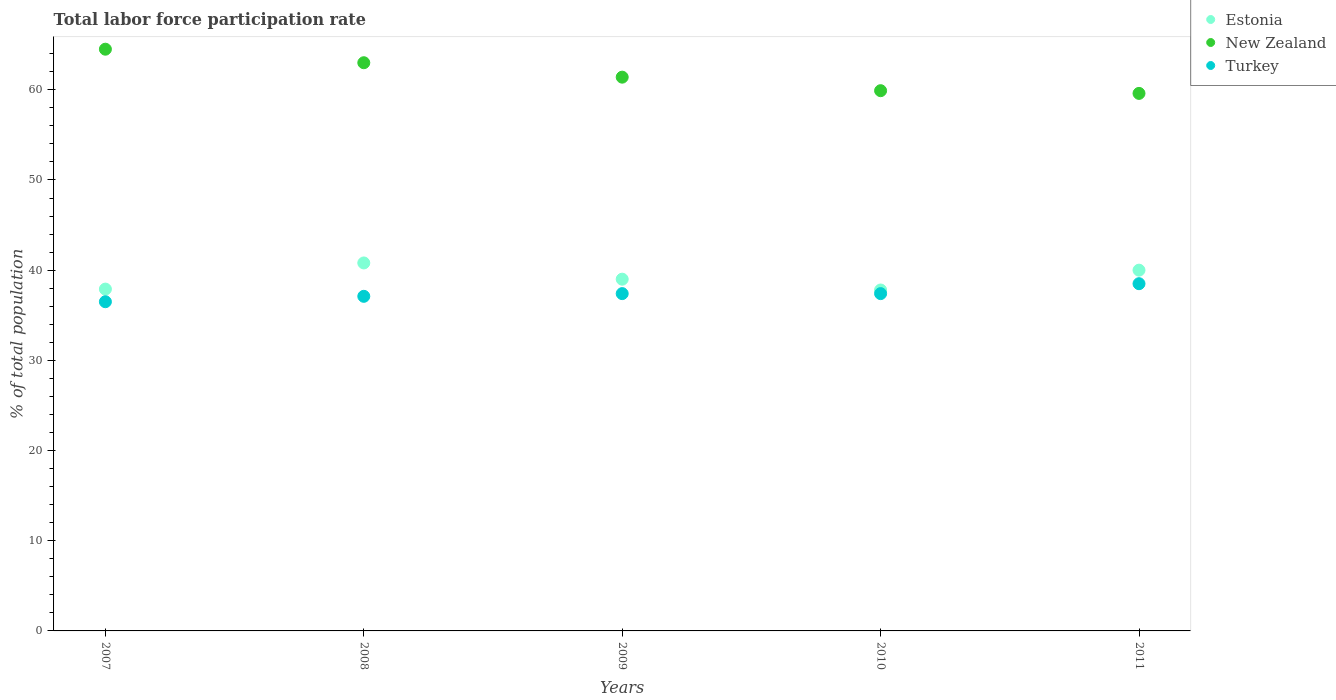How many different coloured dotlines are there?
Provide a short and direct response. 3. Is the number of dotlines equal to the number of legend labels?
Your response must be concise. Yes. What is the total labor force participation rate in Turkey in 2008?
Make the answer very short. 37.1. Across all years, what is the maximum total labor force participation rate in New Zealand?
Offer a terse response. 64.5. Across all years, what is the minimum total labor force participation rate in Turkey?
Your response must be concise. 36.5. In which year was the total labor force participation rate in New Zealand minimum?
Offer a very short reply. 2011. What is the total total labor force participation rate in New Zealand in the graph?
Make the answer very short. 308.4. What is the difference between the total labor force participation rate in New Zealand in 2007 and that in 2008?
Ensure brevity in your answer.  1.5. What is the difference between the total labor force participation rate in Turkey in 2007 and the total labor force participation rate in New Zealand in 2008?
Offer a very short reply. -26.5. What is the average total labor force participation rate in New Zealand per year?
Make the answer very short. 61.68. In the year 2009, what is the difference between the total labor force participation rate in Estonia and total labor force participation rate in Turkey?
Provide a short and direct response. 1.6. In how many years, is the total labor force participation rate in New Zealand greater than 14 %?
Your response must be concise. 5. What is the ratio of the total labor force participation rate in New Zealand in 2008 to that in 2011?
Offer a very short reply. 1.06. Is the total labor force participation rate in New Zealand in 2008 less than that in 2010?
Your answer should be compact. No. What is the difference between the highest and the second highest total labor force participation rate in Turkey?
Keep it short and to the point. 1.1. What is the difference between the highest and the lowest total labor force participation rate in New Zealand?
Keep it short and to the point. 4.9. Is the sum of the total labor force participation rate in New Zealand in 2007 and 2010 greater than the maximum total labor force participation rate in Turkey across all years?
Make the answer very short. Yes. Is it the case that in every year, the sum of the total labor force participation rate in New Zealand and total labor force participation rate in Turkey  is greater than the total labor force participation rate in Estonia?
Offer a terse response. Yes. What is the difference between two consecutive major ticks on the Y-axis?
Provide a succinct answer. 10. Are the values on the major ticks of Y-axis written in scientific E-notation?
Provide a succinct answer. No. Does the graph contain grids?
Your answer should be compact. No. Where does the legend appear in the graph?
Keep it short and to the point. Top right. How are the legend labels stacked?
Make the answer very short. Vertical. What is the title of the graph?
Provide a succinct answer. Total labor force participation rate. What is the label or title of the Y-axis?
Ensure brevity in your answer.  % of total population. What is the % of total population of Estonia in 2007?
Make the answer very short. 37.9. What is the % of total population in New Zealand in 2007?
Ensure brevity in your answer.  64.5. What is the % of total population of Turkey in 2007?
Your answer should be very brief. 36.5. What is the % of total population of Estonia in 2008?
Ensure brevity in your answer.  40.8. What is the % of total population of Turkey in 2008?
Make the answer very short. 37.1. What is the % of total population of New Zealand in 2009?
Keep it short and to the point. 61.4. What is the % of total population in Turkey in 2009?
Provide a succinct answer. 37.4. What is the % of total population in Estonia in 2010?
Give a very brief answer. 37.8. What is the % of total population of New Zealand in 2010?
Your answer should be very brief. 59.9. What is the % of total population of Turkey in 2010?
Give a very brief answer. 37.4. What is the % of total population of New Zealand in 2011?
Your response must be concise. 59.6. What is the % of total population of Turkey in 2011?
Give a very brief answer. 38.5. Across all years, what is the maximum % of total population of Estonia?
Provide a succinct answer. 40.8. Across all years, what is the maximum % of total population of New Zealand?
Give a very brief answer. 64.5. Across all years, what is the maximum % of total population in Turkey?
Ensure brevity in your answer.  38.5. Across all years, what is the minimum % of total population of Estonia?
Your response must be concise. 37.8. Across all years, what is the minimum % of total population of New Zealand?
Offer a terse response. 59.6. Across all years, what is the minimum % of total population of Turkey?
Offer a terse response. 36.5. What is the total % of total population of Estonia in the graph?
Give a very brief answer. 195.5. What is the total % of total population of New Zealand in the graph?
Give a very brief answer. 308.4. What is the total % of total population in Turkey in the graph?
Your answer should be compact. 186.9. What is the difference between the % of total population of Estonia in 2007 and that in 2008?
Ensure brevity in your answer.  -2.9. What is the difference between the % of total population of Turkey in 2007 and that in 2008?
Your response must be concise. -0.6. What is the difference between the % of total population of Estonia in 2007 and that in 2009?
Provide a succinct answer. -1.1. What is the difference between the % of total population of Turkey in 2007 and that in 2009?
Ensure brevity in your answer.  -0.9. What is the difference between the % of total population in Turkey in 2007 and that in 2010?
Your answer should be compact. -0.9. What is the difference between the % of total population in Turkey in 2007 and that in 2011?
Ensure brevity in your answer.  -2. What is the difference between the % of total population in New Zealand in 2008 and that in 2010?
Offer a terse response. 3.1. What is the difference between the % of total population of Turkey in 2008 and that in 2011?
Your answer should be very brief. -1.4. What is the difference between the % of total population in Estonia in 2009 and that in 2010?
Ensure brevity in your answer.  1.2. What is the difference between the % of total population in New Zealand in 2009 and that in 2010?
Ensure brevity in your answer.  1.5. What is the difference between the % of total population in Estonia in 2010 and that in 2011?
Offer a terse response. -2.2. What is the difference between the % of total population in New Zealand in 2010 and that in 2011?
Offer a very short reply. 0.3. What is the difference between the % of total population in Turkey in 2010 and that in 2011?
Provide a succinct answer. -1.1. What is the difference between the % of total population in Estonia in 2007 and the % of total population in New Zealand in 2008?
Offer a terse response. -25.1. What is the difference between the % of total population in Estonia in 2007 and the % of total population in Turkey in 2008?
Give a very brief answer. 0.8. What is the difference between the % of total population in New Zealand in 2007 and the % of total population in Turkey in 2008?
Offer a very short reply. 27.4. What is the difference between the % of total population in Estonia in 2007 and the % of total population in New Zealand in 2009?
Offer a very short reply. -23.5. What is the difference between the % of total population in New Zealand in 2007 and the % of total population in Turkey in 2009?
Offer a very short reply. 27.1. What is the difference between the % of total population of Estonia in 2007 and the % of total population of New Zealand in 2010?
Ensure brevity in your answer.  -22. What is the difference between the % of total population of Estonia in 2007 and the % of total population of Turkey in 2010?
Offer a terse response. 0.5. What is the difference between the % of total population in New Zealand in 2007 and the % of total population in Turkey in 2010?
Keep it short and to the point. 27.1. What is the difference between the % of total population in Estonia in 2007 and the % of total population in New Zealand in 2011?
Give a very brief answer. -21.7. What is the difference between the % of total population in Estonia in 2007 and the % of total population in Turkey in 2011?
Ensure brevity in your answer.  -0.6. What is the difference between the % of total population in Estonia in 2008 and the % of total population in New Zealand in 2009?
Offer a very short reply. -20.6. What is the difference between the % of total population in New Zealand in 2008 and the % of total population in Turkey in 2009?
Provide a short and direct response. 25.6. What is the difference between the % of total population of Estonia in 2008 and the % of total population of New Zealand in 2010?
Provide a succinct answer. -19.1. What is the difference between the % of total population in New Zealand in 2008 and the % of total population in Turkey in 2010?
Provide a succinct answer. 25.6. What is the difference between the % of total population of Estonia in 2008 and the % of total population of New Zealand in 2011?
Keep it short and to the point. -18.8. What is the difference between the % of total population in New Zealand in 2008 and the % of total population in Turkey in 2011?
Keep it short and to the point. 24.5. What is the difference between the % of total population of Estonia in 2009 and the % of total population of New Zealand in 2010?
Provide a short and direct response. -20.9. What is the difference between the % of total population of Estonia in 2009 and the % of total population of Turkey in 2010?
Your answer should be compact. 1.6. What is the difference between the % of total population in Estonia in 2009 and the % of total population in New Zealand in 2011?
Your response must be concise. -20.6. What is the difference between the % of total population of New Zealand in 2009 and the % of total population of Turkey in 2011?
Your response must be concise. 22.9. What is the difference between the % of total population of Estonia in 2010 and the % of total population of New Zealand in 2011?
Your answer should be compact. -21.8. What is the difference between the % of total population of New Zealand in 2010 and the % of total population of Turkey in 2011?
Ensure brevity in your answer.  21.4. What is the average % of total population of Estonia per year?
Make the answer very short. 39.1. What is the average % of total population in New Zealand per year?
Your response must be concise. 61.68. What is the average % of total population in Turkey per year?
Your response must be concise. 37.38. In the year 2007, what is the difference between the % of total population in Estonia and % of total population in New Zealand?
Your answer should be very brief. -26.6. In the year 2008, what is the difference between the % of total population of Estonia and % of total population of New Zealand?
Provide a short and direct response. -22.2. In the year 2008, what is the difference between the % of total population of Estonia and % of total population of Turkey?
Keep it short and to the point. 3.7. In the year 2008, what is the difference between the % of total population in New Zealand and % of total population in Turkey?
Provide a succinct answer. 25.9. In the year 2009, what is the difference between the % of total population of Estonia and % of total population of New Zealand?
Provide a short and direct response. -22.4. In the year 2009, what is the difference between the % of total population in New Zealand and % of total population in Turkey?
Your answer should be very brief. 24. In the year 2010, what is the difference between the % of total population of Estonia and % of total population of New Zealand?
Your answer should be compact. -22.1. In the year 2010, what is the difference between the % of total population in Estonia and % of total population in Turkey?
Keep it short and to the point. 0.4. In the year 2011, what is the difference between the % of total population in Estonia and % of total population in New Zealand?
Offer a terse response. -19.6. In the year 2011, what is the difference between the % of total population of Estonia and % of total population of Turkey?
Provide a succinct answer. 1.5. In the year 2011, what is the difference between the % of total population of New Zealand and % of total population of Turkey?
Provide a short and direct response. 21.1. What is the ratio of the % of total population in Estonia in 2007 to that in 2008?
Keep it short and to the point. 0.93. What is the ratio of the % of total population in New Zealand in 2007 to that in 2008?
Ensure brevity in your answer.  1.02. What is the ratio of the % of total population in Turkey in 2007 to that in 2008?
Give a very brief answer. 0.98. What is the ratio of the % of total population of Estonia in 2007 to that in 2009?
Keep it short and to the point. 0.97. What is the ratio of the % of total population in New Zealand in 2007 to that in 2009?
Give a very brief answer. 1.05. What is the ratio of the % of total population of Turkey in 2007 to that in 2009?
Your answer should be very brief. 0.98. What is the ratio of the % of total population of New Zealand in 2007 to that in 2010?
Offer a very short reply. 1.08. What is the ratio of the % of total population of Turkey in 2007 to that in 2010?
Your answer should be very brief. 0.98. What is the ratio of the % of total population in Estonia in 2007 to that in 2011?
Provide a succinct answer. 0.95. What is the ratio of the % of total population in New Zealand in 2007 to that in 2011?
Your answer should be compact. 1.08. What is the ratio of the % of total population of Turkey in 2007 to that in 2011?
Your response must be concise. 0.95. What is the ratio of the % of total population of Estonia in 2008 to that in 2009?
Provide a succinct answer. 1.05. What is the ratio of the % of total population of New Zealand in 2008 to that in 2009?
Make the answer very short. 1.03. What is the ratio of the % of total population of Estonia in 2008 to that in 2010?
Your response must be concise. 1.08. What is the ratio of the % of total population in New Zealand in 2008 to that in 2010?
Your answer should be compact. 1.05. What is the ratio of the % of total population of Turkey in 2008 to that in 2010?
Provide a succinct answer. 0.99. What is the ratio of the % of total population in New Zealand in 2008 to that in 2011?
Give a very brief answer. 1.06. What is the ratio of the % of total population of Turkey in 2008 to that in 2011?
Provide a succinct answer. 0.96. What is the ratio of the % of total population in Estonia in 2009 to that in 2010?
Give a very brief answer. 1.03. What is the ratio of the % of total population of Turkey in 2009 to that in 2010?
Provide a short and direct response. 1. What is the ratio of the % of total population in Estonia in 2009 to that in 2011?
Your answer should be compact. 0.97. What is the ratio of the % of total population in New Zealand in 2009 to that in 2011?
Give a very brief answer. 1.03. What is the ratio of the % of total population in Turkey in 2009 to that in 2011?
Keep it short and to the point. 0.97. What is the ratio of the % of total population in Estonia in 2010 to that in 2011?
Give a very brief answer. 0.94. What is the ratio of the % of total population of New Zealand in 2010 to that in 2011?
Your response must be concise. 1. What is the ratio of the % of total population in Turkey in 2010 to that in 2011?
Your answer should be very brief. 0.97. What is the difference between the highest and the second highest % of total population in Estonia?
Your answer should be compact. 0.8. What is the difference between the highest and the second highest % of total population of New Zealand?
Ensure brevity in your answer.  1.5. What is the difference between the highest and the second highest % of total population in Turkey?
Offer a terse response. 1.1. What is the difference between the highest and the lowest % of total population of Estonia?
Your response must be concise. 3. What is the difference between the highest and the lowest % of total population of New Zealand?
Keep it short and to the point. 4.9. 